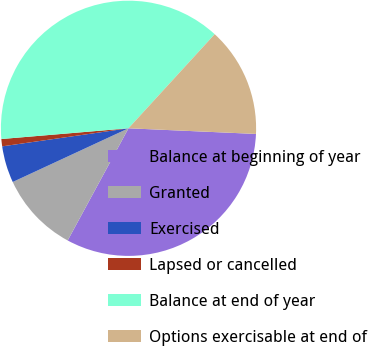<chart> <loc_0><loc_0><loc_500><loc_500><pie_chart><fcel>Balance at beginning of year<fcel>Granted<fcel>Exercised<fcel>Lapsed or cancelled<fcel>Balance at end of year<fcel>Options exercisable at end of<nl><fcel>32.2%<fcel>10.18%<fcel>4.65%<fcel>0.92%<fcel>38.14%<fcel>13.9%<nl></chart> 